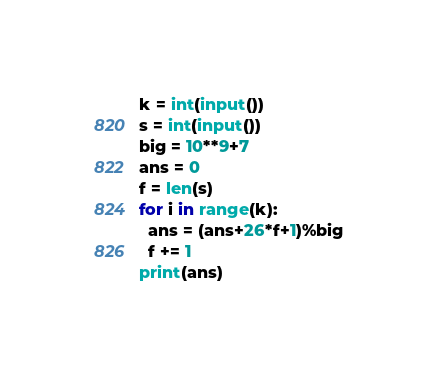<code> <loc_0><loc_0><loc_500><loc_500><_Python_>k = int(input())
s = int(input())
big = 10**9+7
ans = 0
f = len(s)
for i in range(k):
  ans = (ans+26*f+1)%big
  f += 1
print(ans)</code> 